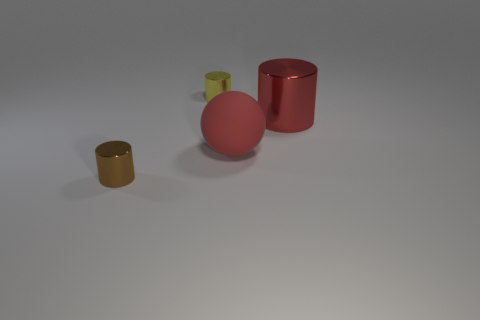What color is the cylinder that is the same size as the red rubber object?
Provide a short and direct response. Red. Are any large yellow matte things visible?
Offer a very short reply. No. Are there fewer big red balls that are in front of the brown shiny cylinder than yellow shiny objects that are right of the red metal thing?
Offer a terse response. No. What is the shape of the big thing on the right side of the red rubber sphere?
Your response must be concise. Cylinder. Is the brown object made of the same material as the yellow thing?
Offer a terse response. Yes. Is there anything else that is made of the same material as the big cylinder?
Offer a terse response. Yes. There is a tiny brown object that is the same shape as the large red metal thing; what is its material?
Give a very brief answer. Metal. Is the number of small brown metal things that are behind the matte object less than the number of red metal cylinders?
Provide a short and direct response. Yes. How many large red spheres are in front of the small yellow shiny cylinder?
Provide a succinct answer. 1. Is the shape of the tiny metal thing that is to the left of the tiny yellow object the same as the tiny thing behind the brown metallic object?
Provide a short and direct response. Yes. 